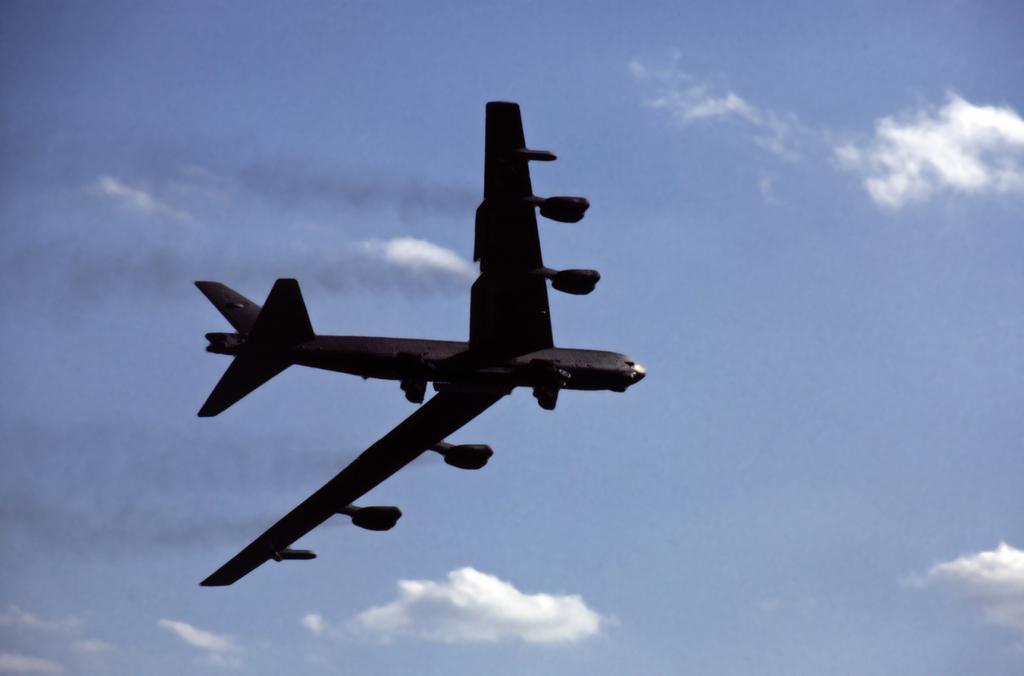Could you give a brief overview of what you see in this image? In this image I can see an aeroplane is flying in the sky. In the background I can see the sky in blue color and the cloud in white color. 